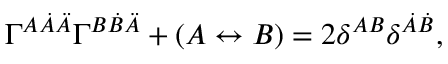Convert formula to latex. <formula><loc_0><loc_0><loc_500><loc_500>\Gamma ^ { A \dot { A } \ddot { A } } \Gamma ^ { B \dot { B } \ddot { A } } + ( A \leftrightarrow B ) = 2 \delta ^ { A B } \delta ^ { \dot { A } \dot { B } } ,</formula> 